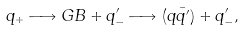Convert formula to latex. <formula><loc_0><loc_0><loc_500><loc_500>q _ { + } \longrightarrow G B + q ^ { \prime } _ { - } \longrightarrow ( q \bar { q ^ { \prime } } ) + q ^ { \prime } _ { - } ,</formula> 